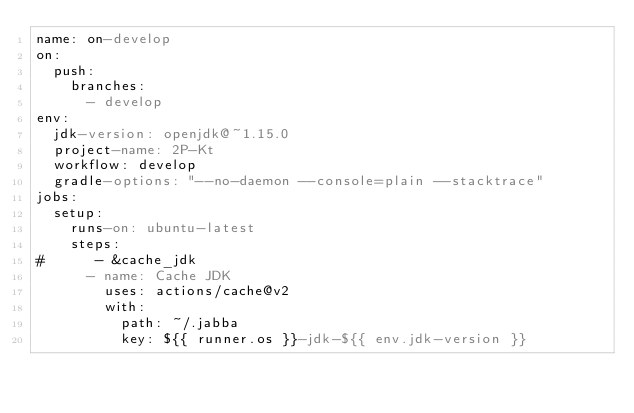Convert code to text. <code><loc_0><loc_0><loc_500><loc_500><_YAML_>name: on-develop
on:
  push:
    branches:
      - develop
env:
  jdk-version: openjdk@~1.15.0
  project-name: 2P-Kt
  workflow: develop
  gradle-options: "--no-daemon --console=plain --stacktrace"
jobs:
  setup:
    runs-on: ubuntu-latest
    steps:
#      - &cache_jdk
      - name: Cache JDK
        uses: actions/cache@v2
        with:
          path: ~/.jabba
          key: ${{ runner.os }}-jdk-${{ env.jdk-version }}</code> 